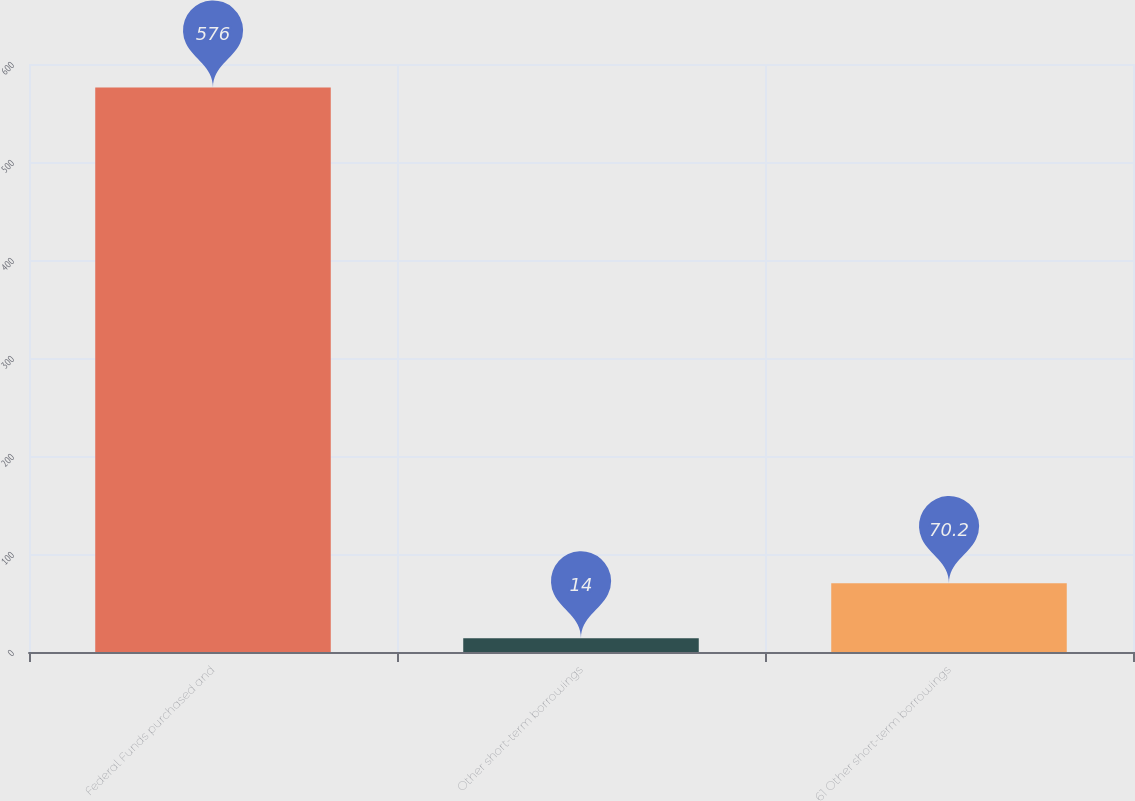Convert chart to OTSL. <chart><loc_0><loc_0><loc_500><loc_500><bar_chart><fcel>Federal Funds purchased and<fcel>Other short-term borrowings<fcel>61 Other short-term borrowings<nl><fcel>576<fcel>14<fcel>70.2<nl></chart> 